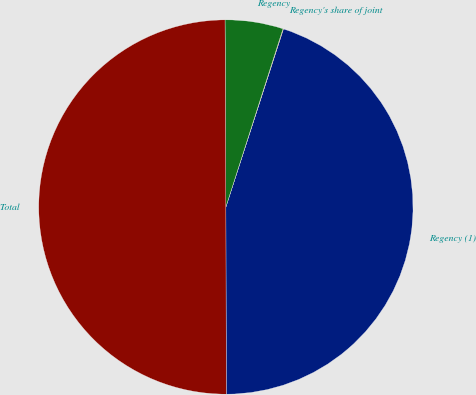<chart> <loc_0><loc_0><loc_500><loc_500><pie_chart><fcel>Regency (1)<fcel>Regency's share of joint<fcel>Regency<fcel>Total<nl><fcel>44.99%<fcel>0.04%<fcel>5.01%<fcel>49.96%<nl></chart> 